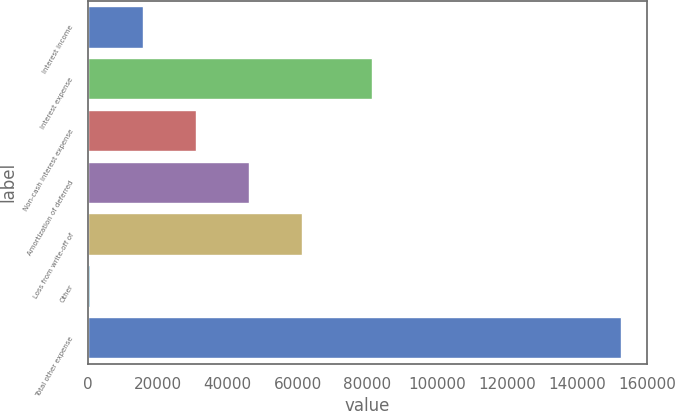Convert chart to OTSL. <chart><loc_0><loc_0><loc_500><loc_500><bar_chart><fcel>Interest income<fcel>Interest expense<fcel>Non-cash interest expense<fcel>Amortization of deferred<fcel>Loss from write-off of<fcel>Other<fcel>Total other expense<nl><fcel>15866.7<fcel>81283<fcel>31041.4<fcel>46216.1<fcel>61390.8<fcel>692<fcel>152439<nl></chart> 